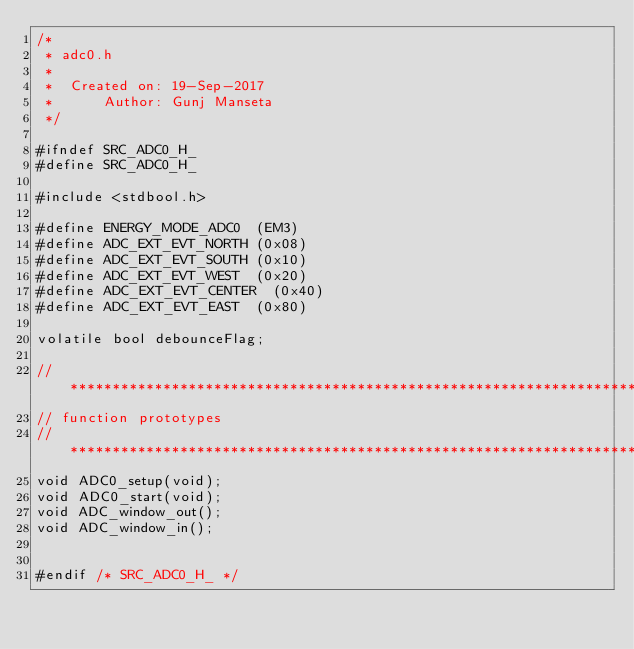Convert code to text. <code><loc_0><loc_0><loc_500><loc_500><_C_>/*
 * adc0.h
 *
 *  Created on: 19-Sep-2017
 *      Author: Gunj Manseta
 */

#ifndef SRC_ADC0_H_
#define SRC_ADC0_H_

#include <stdbool.h>

#define ENERGY_MODE_ADC0 	(EM3)
#define ADC_EXT_EVT_NORTH	(0x08)
#define ADC_EXT_EVT_SOUTH	(0x10)
#define ADC_EXT_EVT_WEST	(0x20)
#define ADC_EXT_EVT_CENTER	(0x40)
#define ADC_EXT_EVT_EAST	(0x80)

volatile bool debounceFlag;

//***********************************************************************************
// function prototypes
//***********************************************************************************
void ADC0_setup(void);
void ADC0_start(void);
void ADC_window_out();
void ADC_window_in();


#endif /* SRC_ADC0_H_ */
</code> 